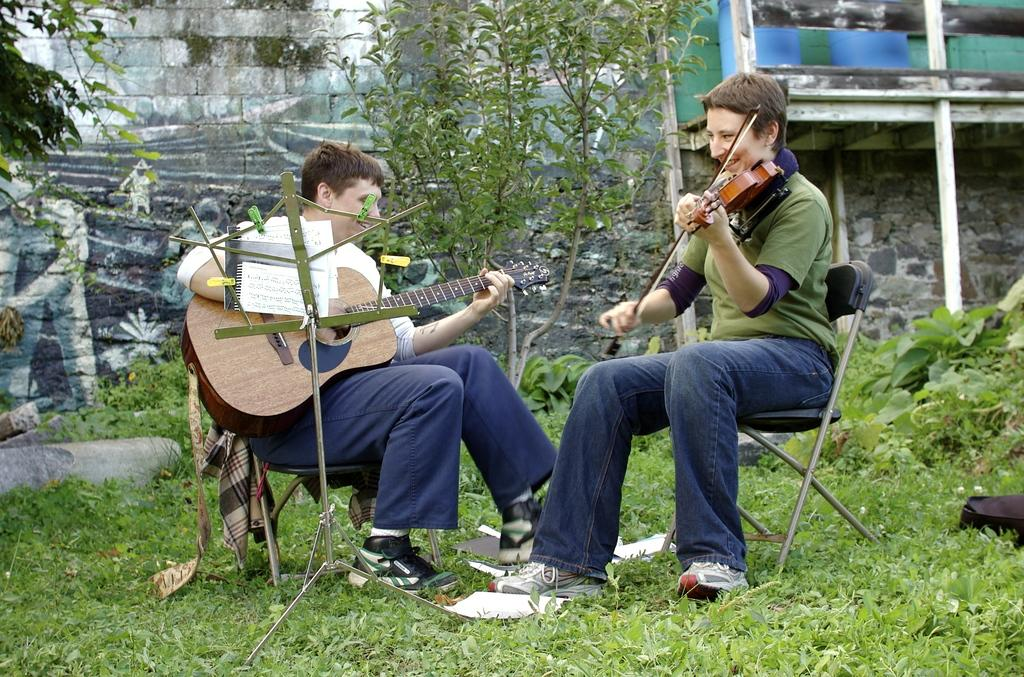How many people are seated in the image? There are two men seated in the image. What are the men doing in the image? One man is playing the violin, and the other man is playing the guitar. What can be seen in the background of the image? There is a tree visible in the image. What type of vegetation is present around the area? There are plants around the area. What type of destruction can be seen happening to the governor's mansion in the image? There is no mention of a governor's mansion or any destruction in the image. The image features two men playing musical instruments and a tree in the background. 